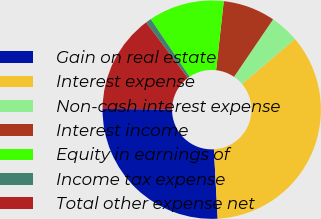<chart> <loc_0><loc_0><loc_500><loc_500><pie_chart><fcel>Gain on real estate<fcel>Interest expense<fcel>Non-cash interest expense<fcel>Interest income<fcel>Equity in earnings of<fcel>Income tax expense<fcel>Total other expense net<nl><fcel>25.97%<fcel>35.35%<fcel>4.29%<fcel>7.74%<fcel>11.19%<fcel>0.83%<fcel>14.64%<nl></chart> 